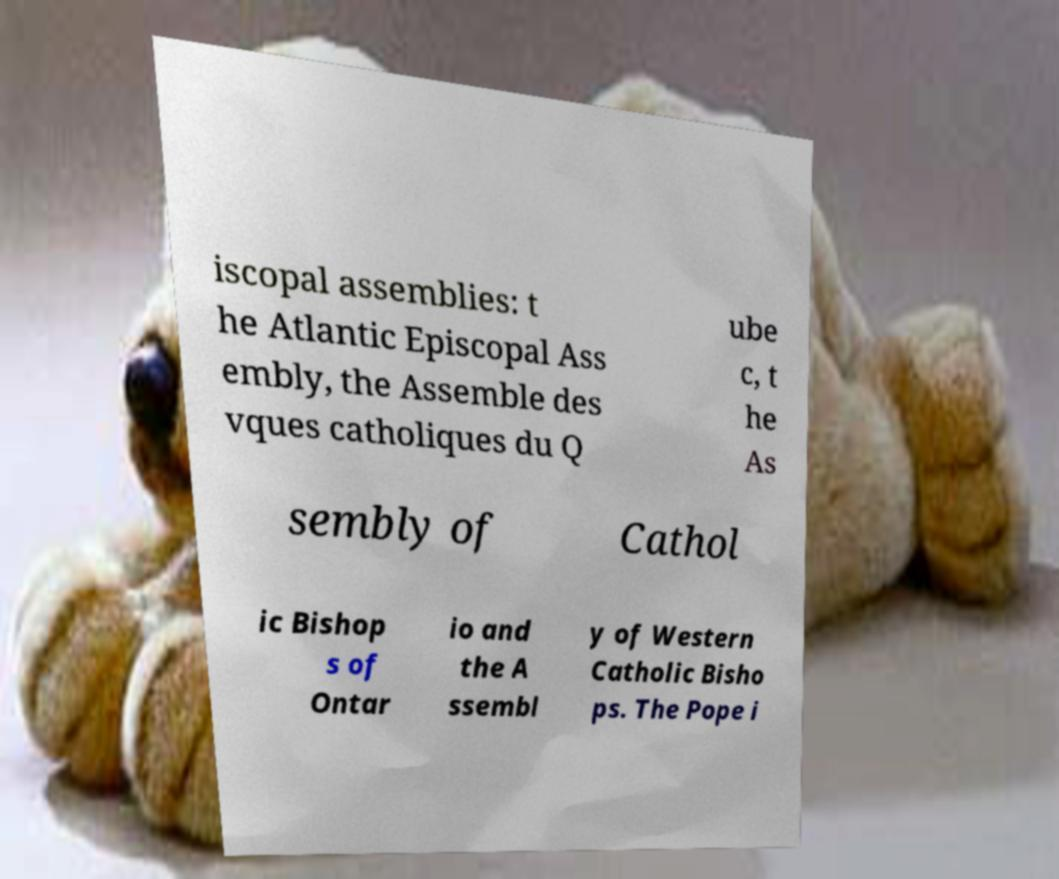For documentation purposes, I need the text within this image transcribed. Could you provide that? iscopal assemblies: t he Atlantic Episcopal Ass embly, the Assemble des vques catholiques du Q ube c, t he As sembly of Cathol ic Bishop s of Ontar io and the A ssembl y of Western Catholic Bisho ps. The Pope i 